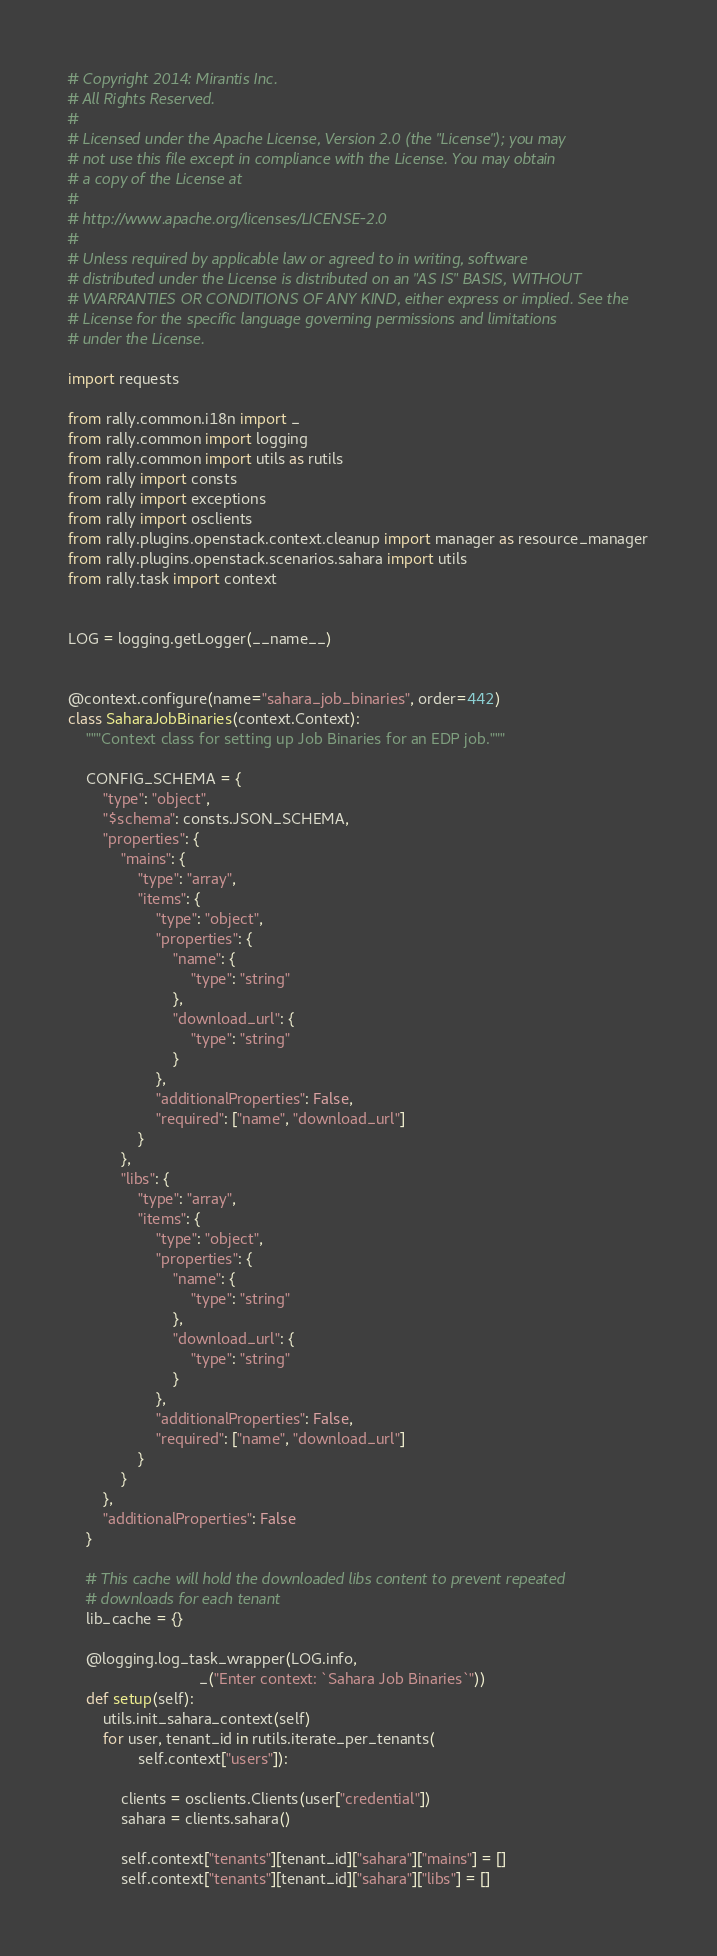Convert code to text. <code><loc_0><loc_0><loc_500><loc_500><_Python_># Copyright 2014: Mirantis Inc.
# All Rights Reserved.
#
# Licensed under the Apache License, Version 2.0 (the "License"); you may
# not use this file except in compliance with the License. You may obtain
# a copy of the License at
#
# http://www.apache.org/licenses/LICENSE-2.0
#
# Unless required by applicable law or agreed to in writing, software
# distributed under the License is distributed on an "AS IS" BASIS, WITHOUT
# WARRANTIES OR CONDITIONS OF ANY KIND, either express or implied. See the
# License for the specific language governing permissions and limitations
# under the License.

import requests

from rally.common.i18n import _
from rally.common import logging
from rally.common import utils as rutils
from rally import consts
from rally import exceptions
from rally import osclients
from rally.plugins.openstack.context.cleanup import manager as resource_manager
from rally.plugins.openstack.scenarios.sahara import utils
from rally.task import context


LOG = logging.getLogger(__name__)


@context.configure(name="sahara_job_binaries", order=442)
class SaharaJobBinaries(context.Context):
    """Context class for setting up Job Binaries for an EDP job."""

    CONFIG_SCHEMA = {
        "type": "object",
        "$schema": consts.JSON_SCHEMA,
        "properties": {
            "mains": {
                "type": "array",
                "items": {
                    "type": "object",
                    "properties": {
                        "name": {
                            "type": "string"
                        },
                        "download_url": {
                            "type": "string"
                        }
                    },
                    "additionalProperties": False,
                    "required": ["name", "download_url"]
                }
            },
            "libs": {
                "type": "array",
                "items": {
                    "type": "object",
                    "properties": {
                        "name": {
                            "type": "string"
                        },
                        "download_url": {
                            "type": "string"
                        }
                    },
                    "additionalProperties": False,
                    "required": ["name", "download_url"]
                }
            }
        },
        "additionalProperties": False
    }

    # This cache will hold the downloaded libs content to prevent repeated
    # downloads for each tenant
    lib_cache = {}

    @logging.log_task_wrapper(LOG.info,
                              _("Enter context: `Sahara Job Binaries`"))
    def setup(self):
        utils.init_sahara_context(self)
        for user, tenant_id in rutils.iterate_per_tenants(
                self.context["users"]):

            clients = osclients.Clients(user["credential"])
            sahara = clients.sahara()

            self.context["tenants"][tenant_id]["sahara"]["mains"] = []
            self.context["tenants"][tenant_id]["sahara"]["libs"] = []
</code> 